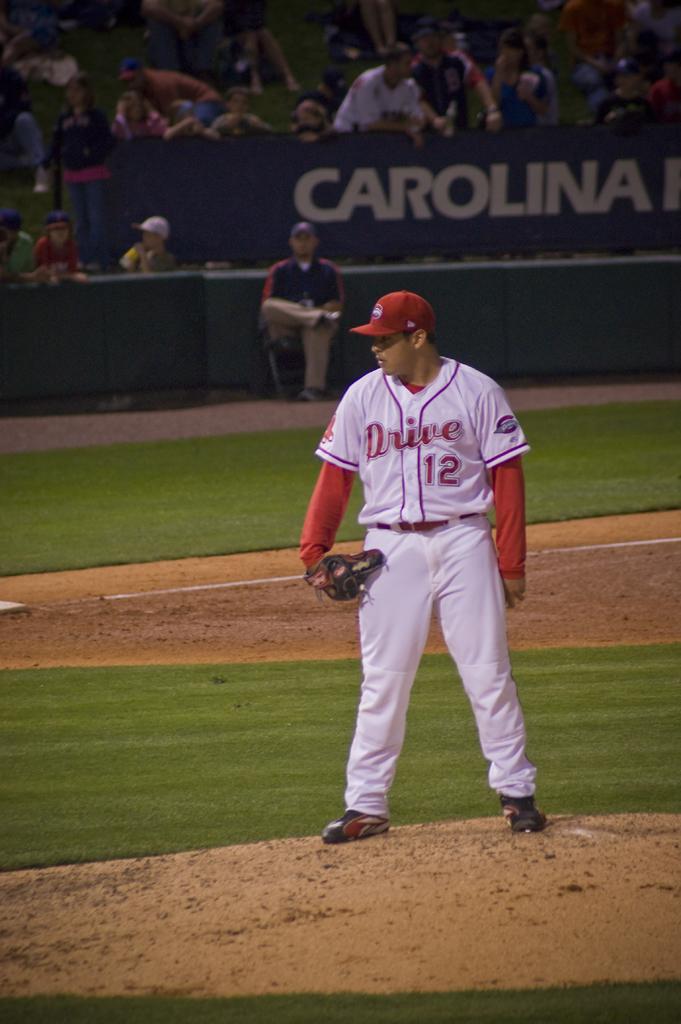Which team does the baseball player play for?
Offer a very short reply. Drive. 